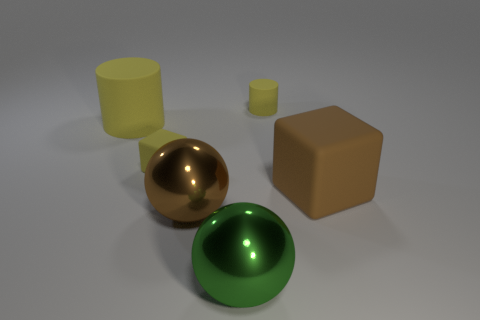Is the small block the same color as the large cylinder?
Make the answer very short. Yes. There is a green ball; are there any yellow rubber things to the left of it?
Offer a very short reply. Yes. Does the brown metal thing have the same size as the rubber cylinder on the right side of the big green ball?
Ensure brevity in your answer.  No. The big rubber object on the right side of the large yellow matte object on the left side of the big brown metal object is what color?
Offer a very short reply. Brown. Do the brown matte thing and the yellow cube have the same size?
Offer a very short reply. No. There is a object that is behind the large brown metal ball and in front of the tiny block; what color is it?
Provide a succinct answer. Brown. What size is the yellow cube?
Your response must be concise. Small. Does the small rubber thing that is behind the large cylinder have the same color as the large rubber cylinder?
Your answer should be very brief. Yes. Is the number of yellow objects that are on the left side of the tiny yellow matte block greater than the number of large brown rubber blocks left of the large rubber block?
Ensure brevity in your answer.  Yes. Is the number of large green things greater than the number of large spheres?
Your response must be concise. No. 